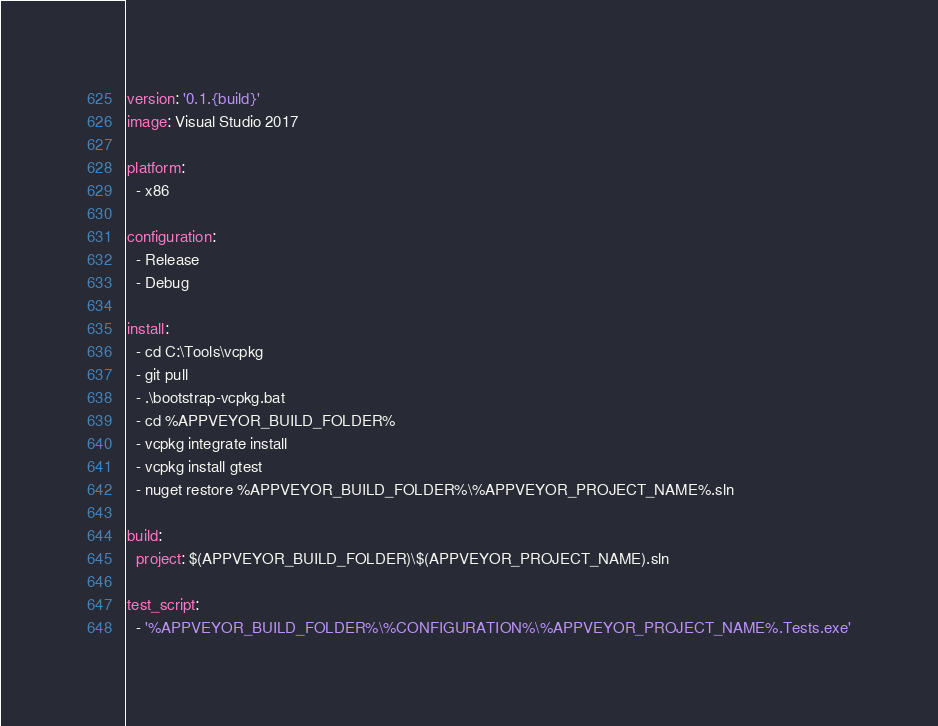Convert code to text. <code><loc_0><loc_0><loc_500><loc_500><_YAML_>version: '0.1.{build}'
image: Visual Studio 2017

platform:
  - x86

configuration:
  - Release
  - Debug

install:
  - cd C:\Tools\vcpkg
  - git pull
  - .\bootstrap-vcpkg.bat
  - cd %APPVEYOR_BUILD_FOLDER%
  - vcpkg integrate install
  - vcpkg install gtest
  - nuget restore %APPVEYOR_BUILD_FOLDER%\%APPVEYOR_PROJECT_NAME%.sln

build:
  project: $(APPVEYOR_BUILD_FOLDER)\$(APPVEYOR_PROJECT_NAME).sln

test_script:
  - '%APPVEYOR_BUILD_FOLDER%\%CONFIGURATION%\%APPVEYOR_PROJECT_NAME%.Tests.exe'</code> 